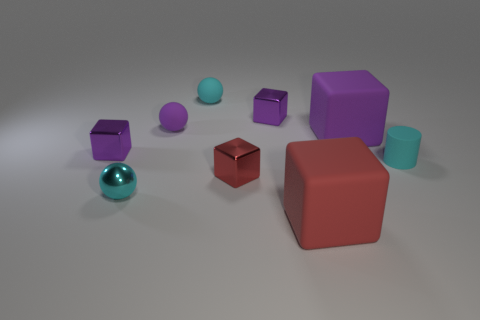Does the tiny cylinder have the same color as the small metal sphere in front of the large purple cube? Yes, the tiny cylinder has a similar teal color to the small metal sphere that's located in front of the large purple cube, showcasing a cohesive and harmonic color palette in this selection of objects. 